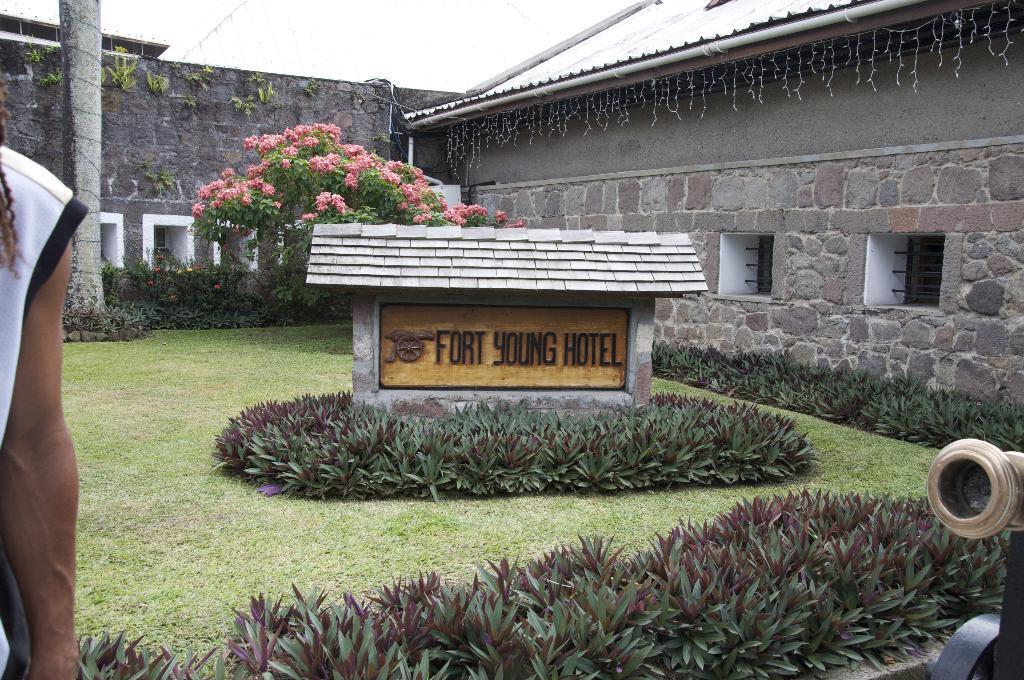How would you summarize this image in a sentence or two? In the foreground of the picture there are plants, grass, cannon and a person's hand. In the center of the picture there are plants, grass, trees, flowers and wall. At the top there is sky and roof of the building. 